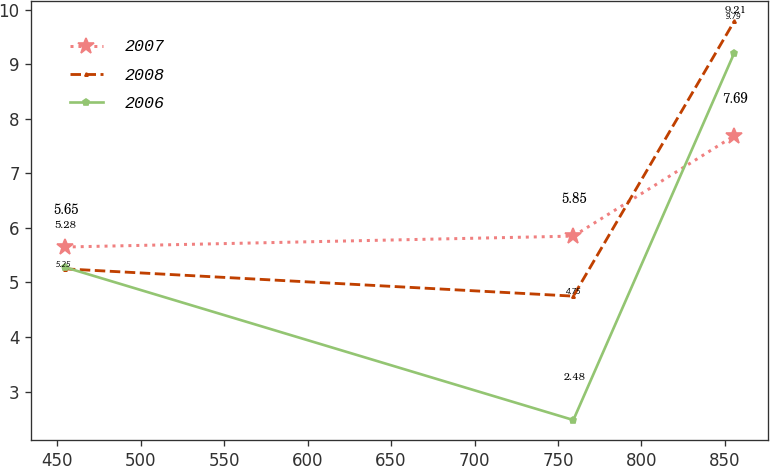Convert chart. <chart><loc_0><loc_0><loc_500><loc_500><line_chart><ecel><fcel>2007<fcel>2008<fcel>2006<nl><fcel>454.58<fcel>5.65<fcel>5.25<fcel>5.28<nl><fcel>759.21<fcel>5.85<fcel>4.75<fcel>2.48<nl><fcel>855.66<fcel>7.69<fcel>9.79<fcel>9.21<nl></chart> 